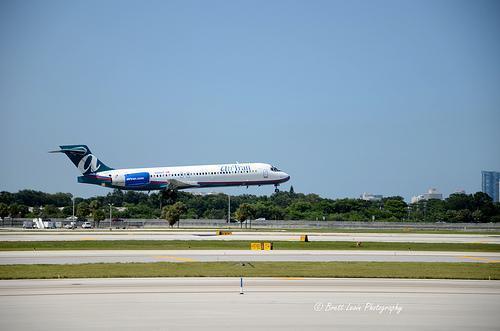How many planes are there?
Give a very brief answer. 1. How many clouds?
Give a very brief answer. 0. 